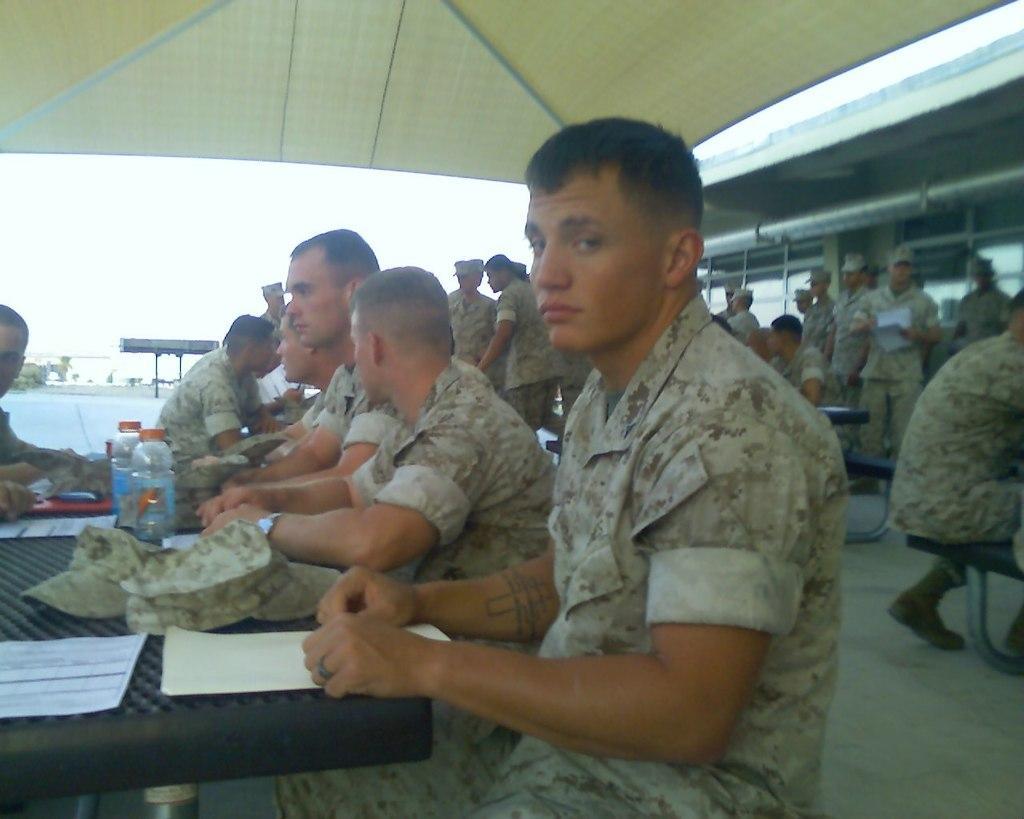Can you describe this image briefly? In this image we can see people, tables, papers, caps, bottles, shed, floor, and few objects. In the background there is sky. 